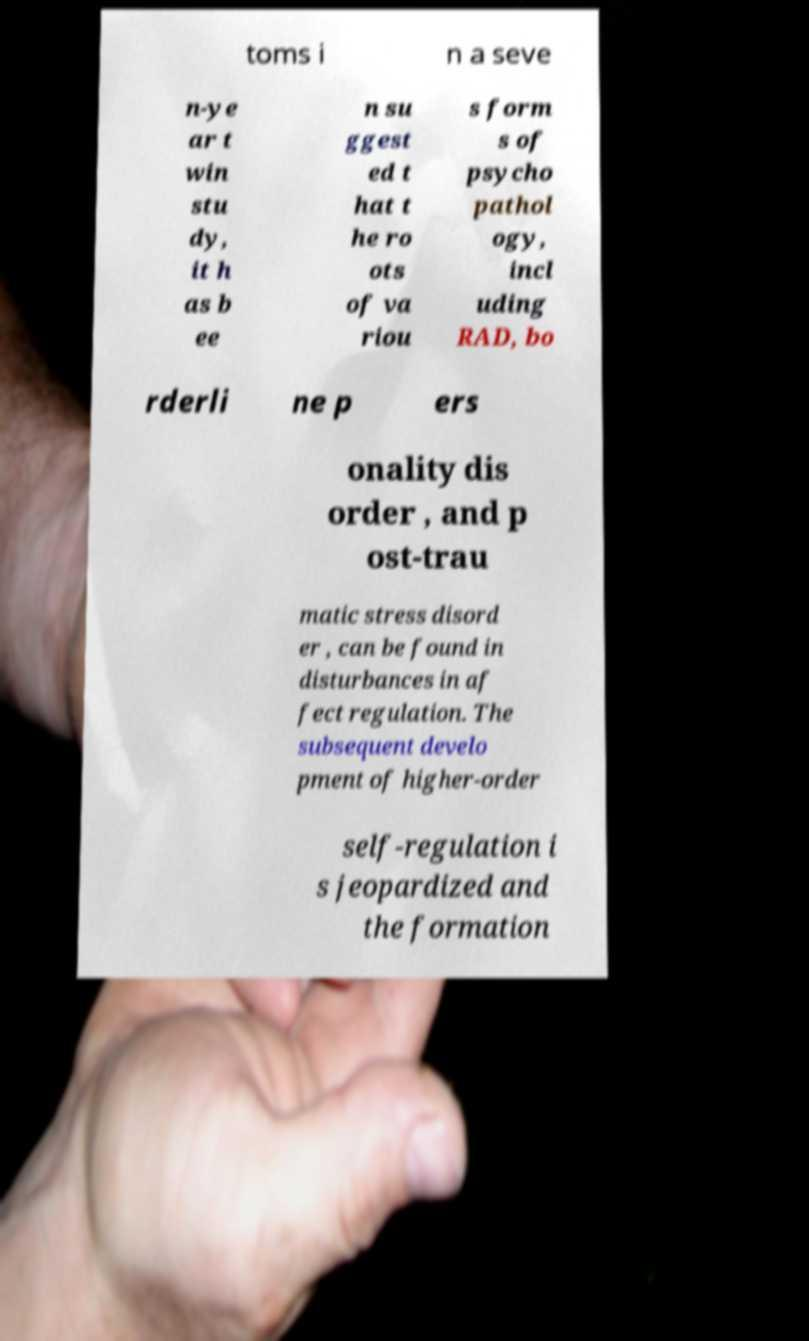Can you accurately transcribe the text from the provided image for me? toms i n a seve n-ye ar t win stu dy, it h as b ee n su ggest ed t hat t he ro ots of va riou s form s of psycho pathol ogy, incl uding RAD, bo rderli ne p ers onality dis order , and p ost-trau matic stress disord er , can be found in disturbances in af fect regulation. The subsequent develo pment of higher-order self-regulation i s jeopardized and the formation 